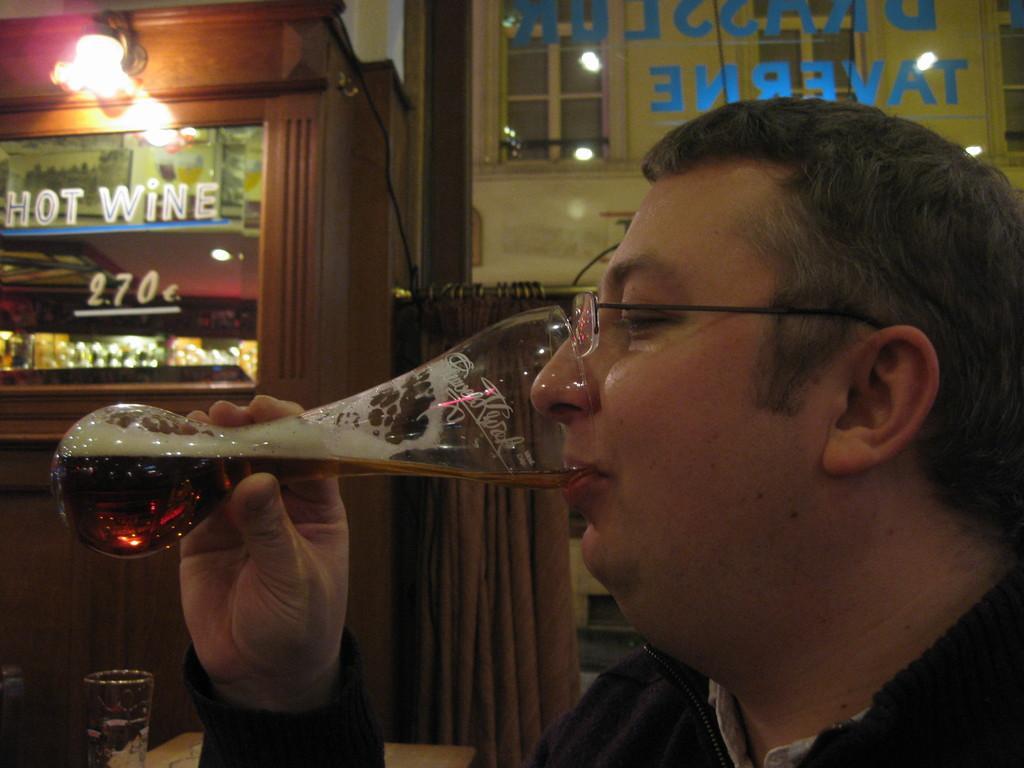Describe this image in one or two sentences. In this Image I see man who is holding the glass and I see that the glass is near his mouth. In the background I see a shop, curtain, glass and the light. 